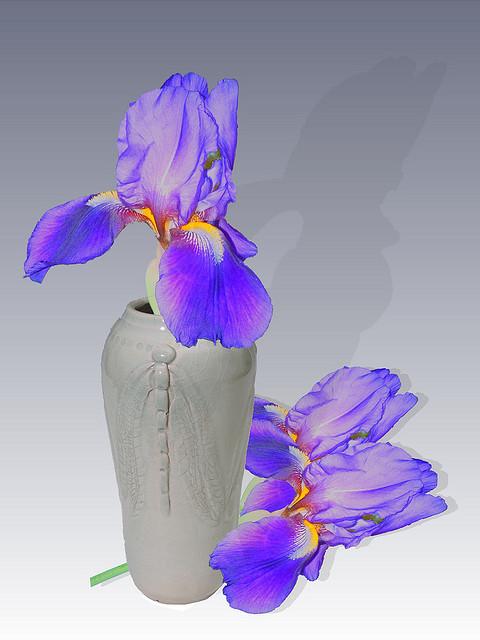What color are the flowers?
Be succinct. Purple. What animal is shown?
Keep it brief. None. What are the flowers placed in?
Answer briefly. Vase. 